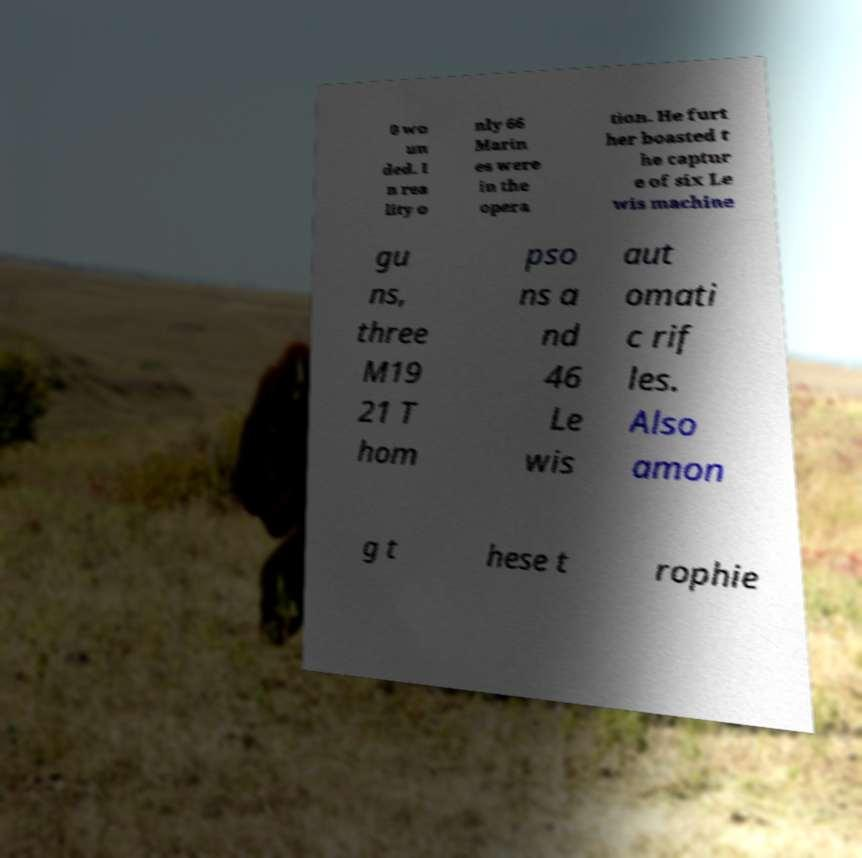Please identify and transcribe the text found in this image. 0 wo un ded. I n rea lity o nly 66 Marin es were in the opera tion. He furt her boasted t he captur e of six Le wis machine gu ns, three M19 21 T hom pso ns a nd 46 Le wis aut omati c rif les. Also amon g t hese t rophie 